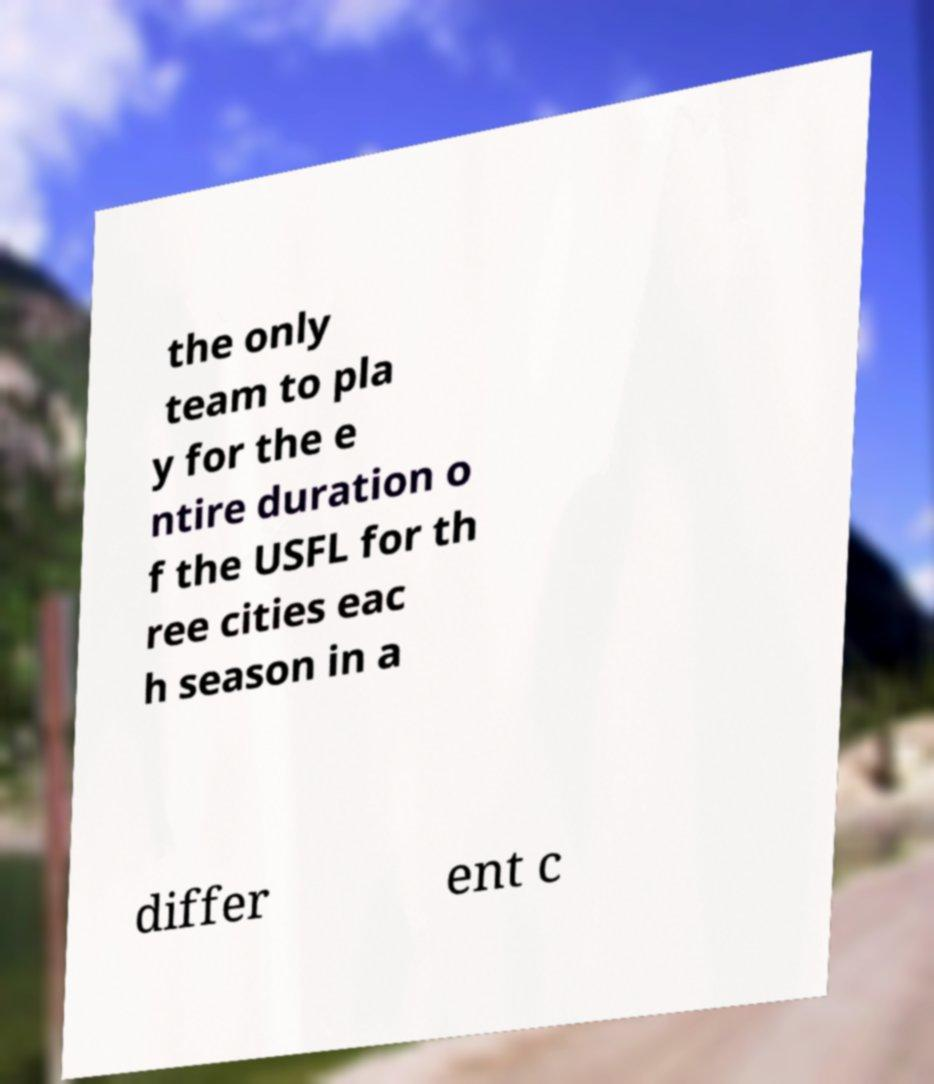Please read and relay the text visible in this image. What does it say? the only team to pla y for the e ntire duration o f the USFL for th ree cities eac h season in a differ ent c 